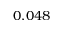Convert formula to latex. <formula><loc_0><loc_0><loc_500><loc_500>0 . 0 4 8</formula> 